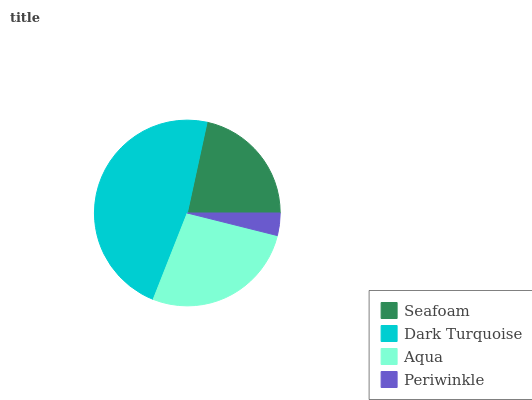Is Periwinkle the minimum?
Answer yes or no. Yes. Is Dark Turquoise the maximum?
Answer yes or no. Yes. Is Aqua the minimum?
Answer yes or no. No. Is Aqua the maximum?
Answer yes or no. No. Is Dark Turquoise greater than Aqua?
Answer yes or no. Yes. Is Aqua less than Dark Turquoise?
Answer yes or no. Yes. Is Aqua greater than Dark Turquoise?
Answer yes or no. No. Is Dark Turquoise less than Aqua?
Answer yes or no. No. Is Aqua the high median?
Answer yes or no. Yes. Is Seafoam the low median?
Answer yes or no. Yes. Is Periwinkle the high median?
Answer yes or no. No. Is Periwinkle the low median?
Answer yes or no. No. 